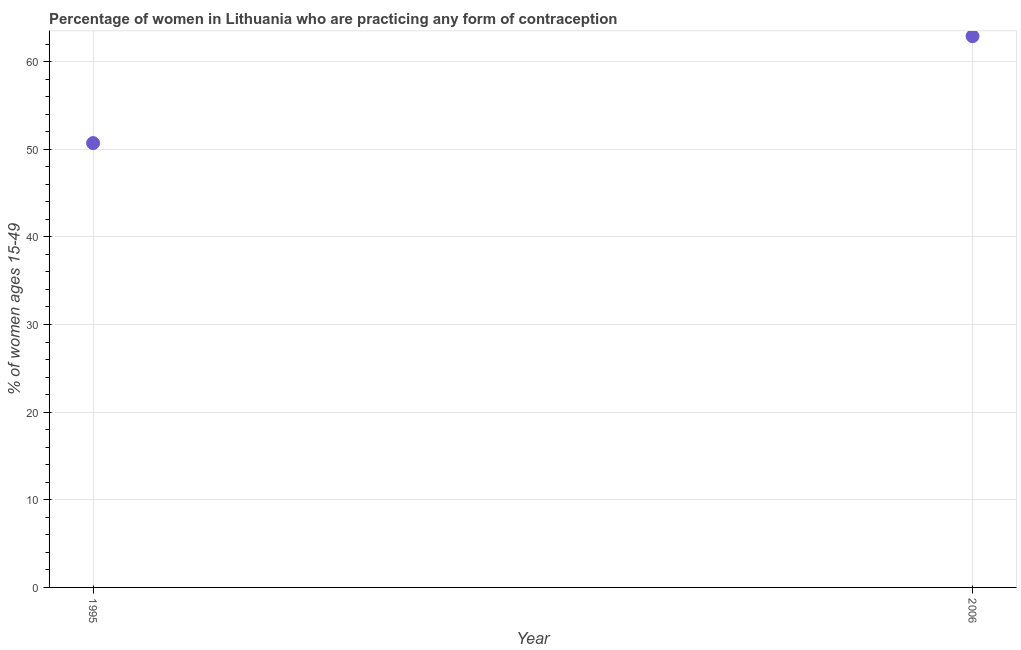What is the contraceptive prevalence in 2006?
Ensure brevity in your answer.  62.9. Across all years, what is the maximum contraceptive prevalence?
Your answer should be very brief. 62.9. Across all years, what is the minimum contraceptive prevalence?
Give a very brief answer. 50.7. What is the sum of the contraceptive prevalence?
Offer a very short reply. 113.6. What is the difference between the contraceptive prevalence in 1995 and 2006?
Your answer should be very brief. -12.2. What is the average contraceptive prevalence per year?
Make the answer very short. 56.8. What is the median contraceptive prevalence?
Keep it short and to the point. 56.8. Do a majority of the years between 2006 and 1995 (inclusive) have contraceptive prevalence greater than 32 %?
Keep it short and to the point. No. What is the ratio of the contraceptive prevalence in 1995 to that in 2006?
Offer a very short reply. 0.81. Is the contraceptive prevalence in 1995 less than that in 2006?
Your response must be concise. Yes. Does the contraceptive prevalence monotonically increase over the years?
Offer a very short reply. Yes. What is the difference between two consecutive major ticks on the Y-axis?
Provide a succinct answer. 10. Does the graph contain any zero values?
Give a very brief answer. No. What is the title of the graph?
Your answer should be compact. Percentage of women in Lithuania who are practicing any form of contraception. What is the label or title of the X-axis?
Offer a very short reply. Year. What is the label or title of the Y-axis?
Your answer should be compact. % of women ages 15-49. What is the % of women ages 15-49 in 1995?
Give a very brief answer. 50.7. What is the % of women ages 15-49 in 2006?
Keep it short and to the point. 62.9. What is the difference between the % of women ages 15-49 in 1995 and 2006?
Give a very brief answer. -12.2. What is the ratio of the % of women ages 15-49 in 1995 to that in 2006?
Make the answer very short. 0.81. 